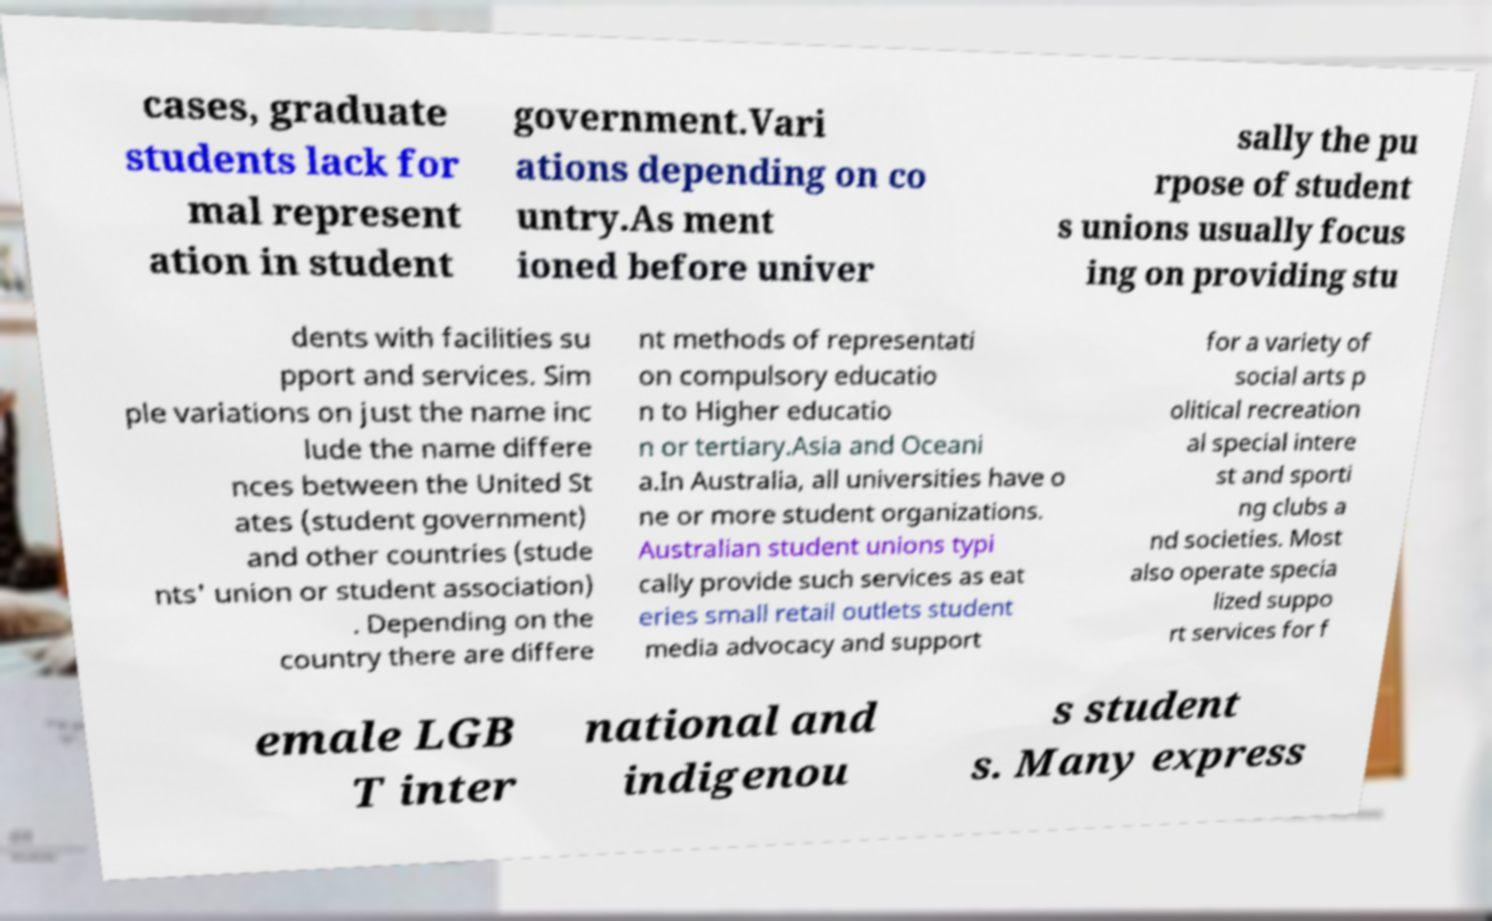Can you read and provide the text displayed in the image?This photo seems to have some interesting text. Can you extract and type it out for me? cases, graduate students lack for mal represent ation in student government.Vari ations depending on co untry.As ment ioned before univer sally the pu rpose of student s unions usually focus ing on providing stu dents with facilities su pport and services. Sim ple variations on just the name inc lude the name differe nces between the United St ates (student government) and other countries (stude nts' union or student association) . Depending on the country there are differe nt methods of representati on compulsory educatio n to Higher educatio n or tertiary.Asia and Oceani a.In Australia, all universities have o ne or more student organizations. Australian student unions typi cally provide such services as eat eries small retail outlets student media advocacy and support for a variety of social arts p olitical recreation al special intere st and sporti ng clubs a nd societies. Most also operate specia lized suppo rt services for f emale LGB T inter national and indigenou s student s. Many express 